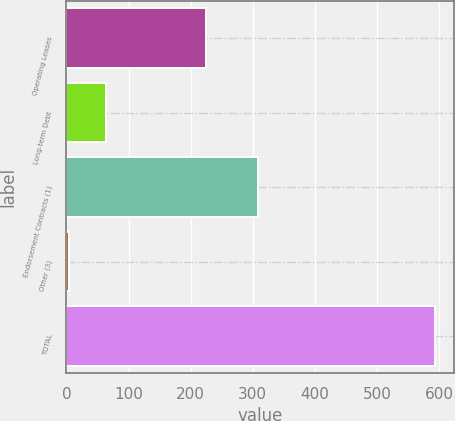Convert chart. <chart><loc_0><loc_0><loc_500><loc_500><bar_chart><fcel>Operating Leases<fcel>Long-term Debt<fcel>Endorsement Contracts (1)<fcel>Other (3)<fcel>TOTAL<nl><fcel>225<fcel>63<fcel>309<fcel>4<fcel>594<nl></chart> 